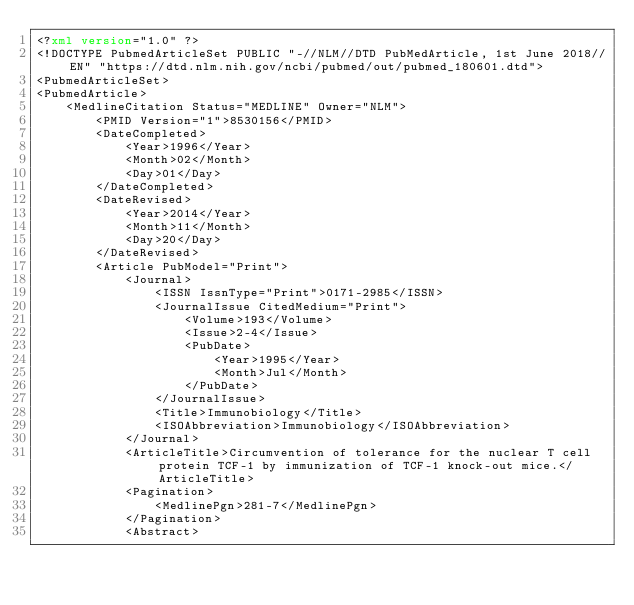<code> <loc_0><loc_0><loc_500><loc_500><_XML_><?xml version="1.0" ?>
<!DOCTYPE PubmedArticleSet PUBLIC "-//NLM//DTD PubMedArticle, 1st June 2018//EN" "https://dtd.nlm.nih.gov/ncbi/pubmed/out/pubmed_180601.dtd">
<PubmedArticleSet>
<PubmedArticle>
    <MedlineCitation Status="MEDLINE" Owner="NLM">
        <PMID Version="1">8530156</PMID>
        <DateCompleted>
            <Year>1996</Year>
            <Month>02</Month>
            <Day>01</Day>
        </DateCompleted>
        <DateRevised>
            <Year>2014</Year>
            <Month>11</Month>
            <Day>20</Day>
        </DateRevised>
        <Article PubModel="Print">
            <Journal>
                <ISSN IssnType="Print">0171-2985</ISSN>
                <JournalIssue CitedMedium="Print">
                    <Volume>193</Volume>
                    <Issue>2-4</Issue>
                    <PubDate>
                        <Year>1995</Year>
                        <Month>Jul</Month>
                    </PubDate>
                </JournalIssue>
                <Title>Immunobiology</Title>
                <ISOAbbreviation>Immunobiology</ISOAbbreviation>
            </Journal>
            <ArticleTitle>Circumvention of tolerance for the nuclear T cell protein TCF-1 by immunization of TCF-1 knock-out mice.</ArticleTitle>
            <Pagination>
                <MedlinePgn>281-7</MedlinePgn>
            </Pagination>
            <Abstract></code> 